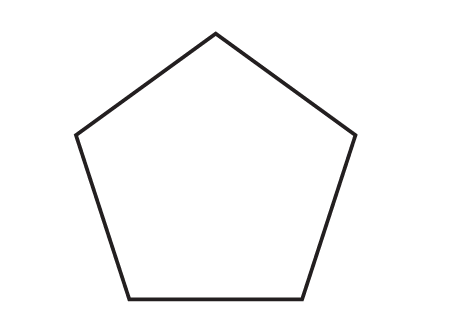Answer the mathemtical geometry problem and directly provide the correct option letter.
Question: What is the measure of an interior angle of a regular pentagon?
Choices: A: 96 B: 108 C: 120 D: 135 B 